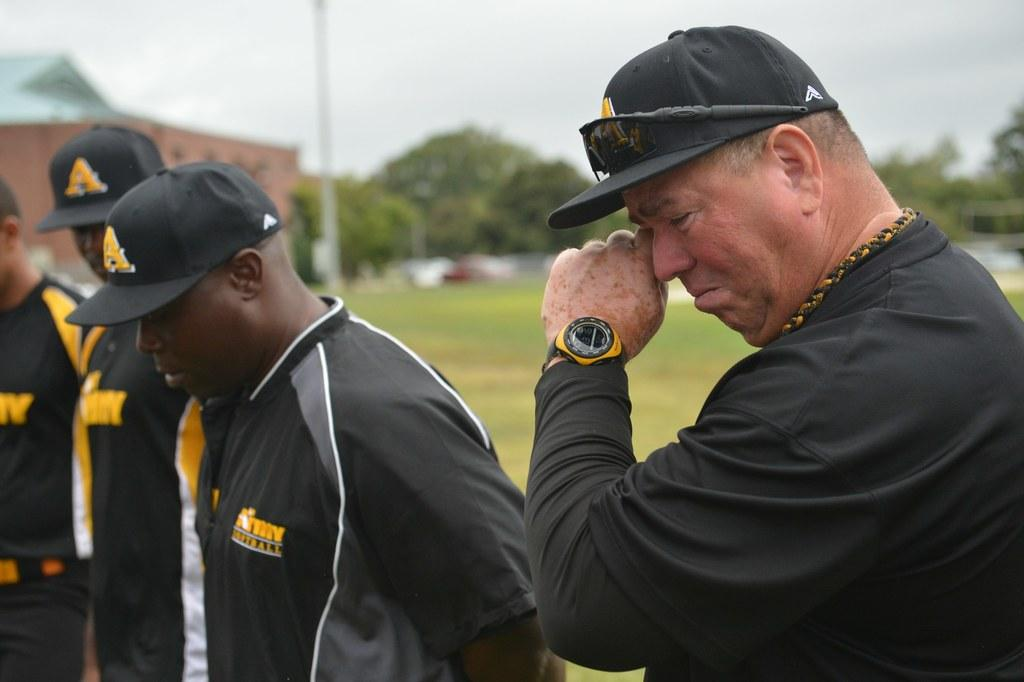What is happening in the foreground of the image? There are men in the foreground of the image. Can you describe the actions of one of the men? One of the men is wiping his eyes. How is the background of the men depicted in the image? The background of the men is blurred. What type of waves are the men riding in the image? There are no waves present in the image; it features men in the foreground with a blurred background. What trade agreement is being discussed by the men in the image? There is no indication of a trade agreement or discussion in the image; it simply shows men in the foreground with one wiping his eyes. 